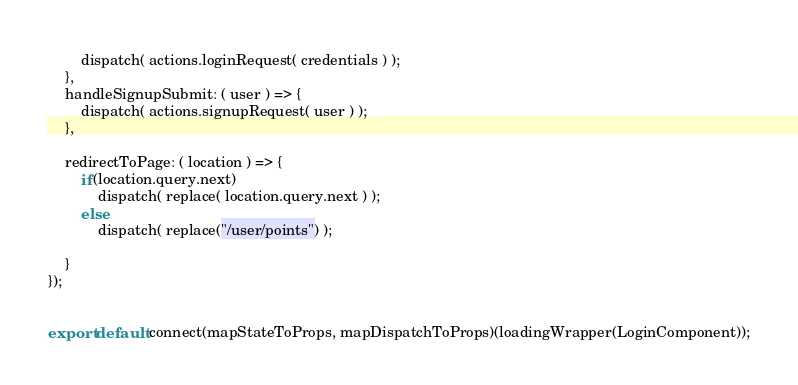<code> <loc_0><loc_0><loc_500><loc_500><_JavaScript_>		dispatch( actions.loginRequest( credentials ) );
	},
	handleSignupSubmit: ( user ) => {
		dispatch( actions.signupRequest( user ) );
	},

	redirectToPage: ( location ) => {
		if(location.query.next)
			dispatch( replace( location.query.next ) );
		else
			dispatch( replace("/user/points") );
		
	}
});


export default connect(mapStateToProps, mapDispatchToProps)(loadingWrapper(LoginComponent));</code> 